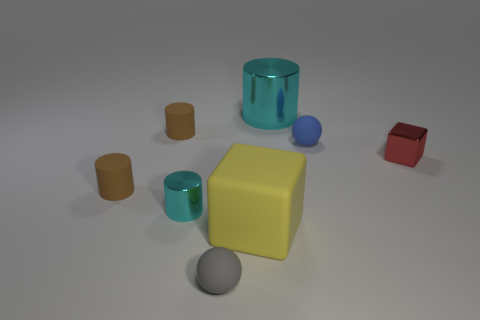Subtract all large cyan metallic cylinders. How many cylinders are left? 3 Subtract 1 cylinders. How many cylinders are left? 3 Subtract all green cylinders. Subtract all blue spheres. How many cylinders are left? 4 Add 1 small blue rubber objects. How many objects exist? 9 Subtract all spheres. How many objects are left? 6 Subtract 1 red cubes. How many objects are left? 7 Subtract all small metal cylinders. Subtract all metal things. How many objects are left? 4 Add 6 big cyan things. How many big cyan things are left? 7 Add 4 brown matte things. How many brown matte things exist? 6 